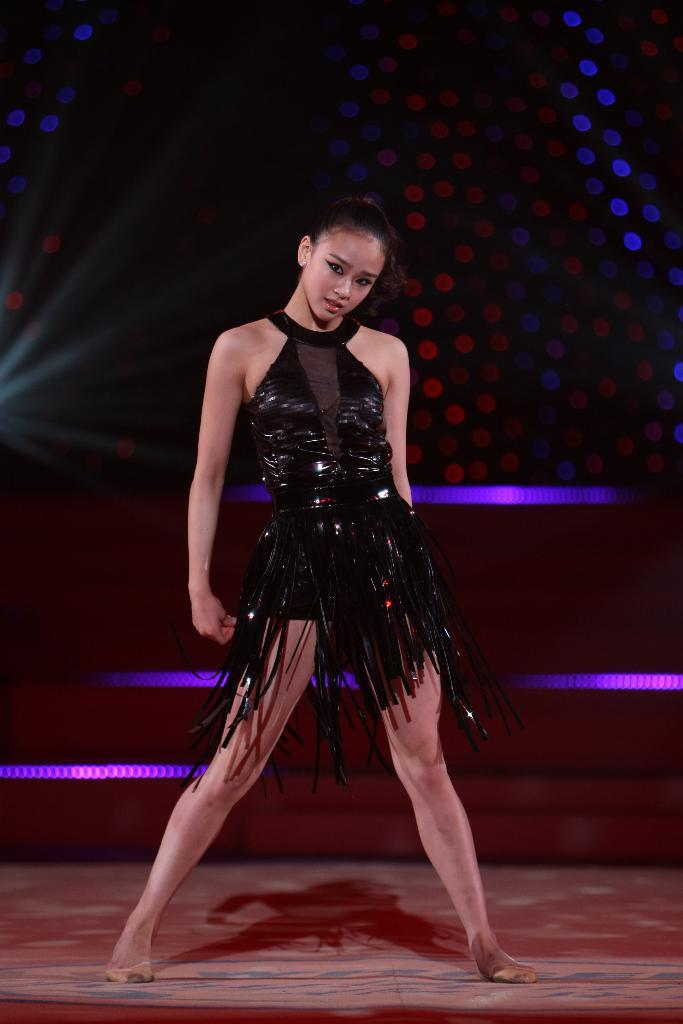What is the main subject of the image? There is a woman standing in the image. What is the woman standing on? The woman is standing on the floor. What can be seen in the background of the image? There are lights visible in the background of the image. What type of amusement can be seen in the image? There is no amusement present in the image; it features a woman standing on the floor with lights in the background. How does the wind affect the woman in the image? There is no wind present in the image, and therefore no effect on the woman can be observed. 